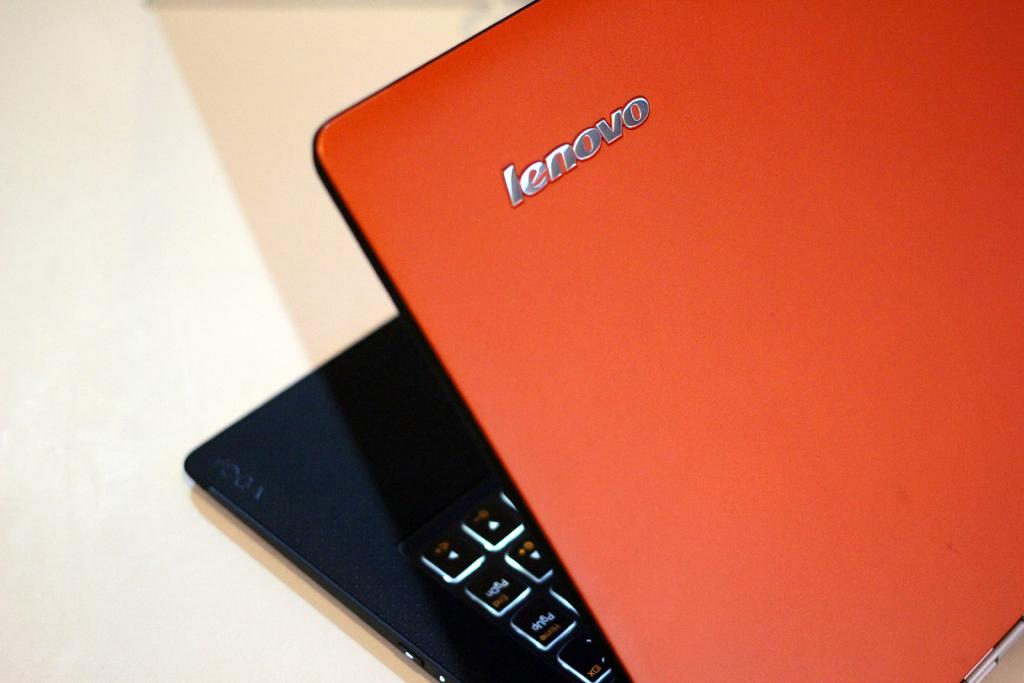What brand is this laptop?
Your answer should be compact. Lenovo. This laptop brand is lenovo?
Keep it short and to the point. Yes. 